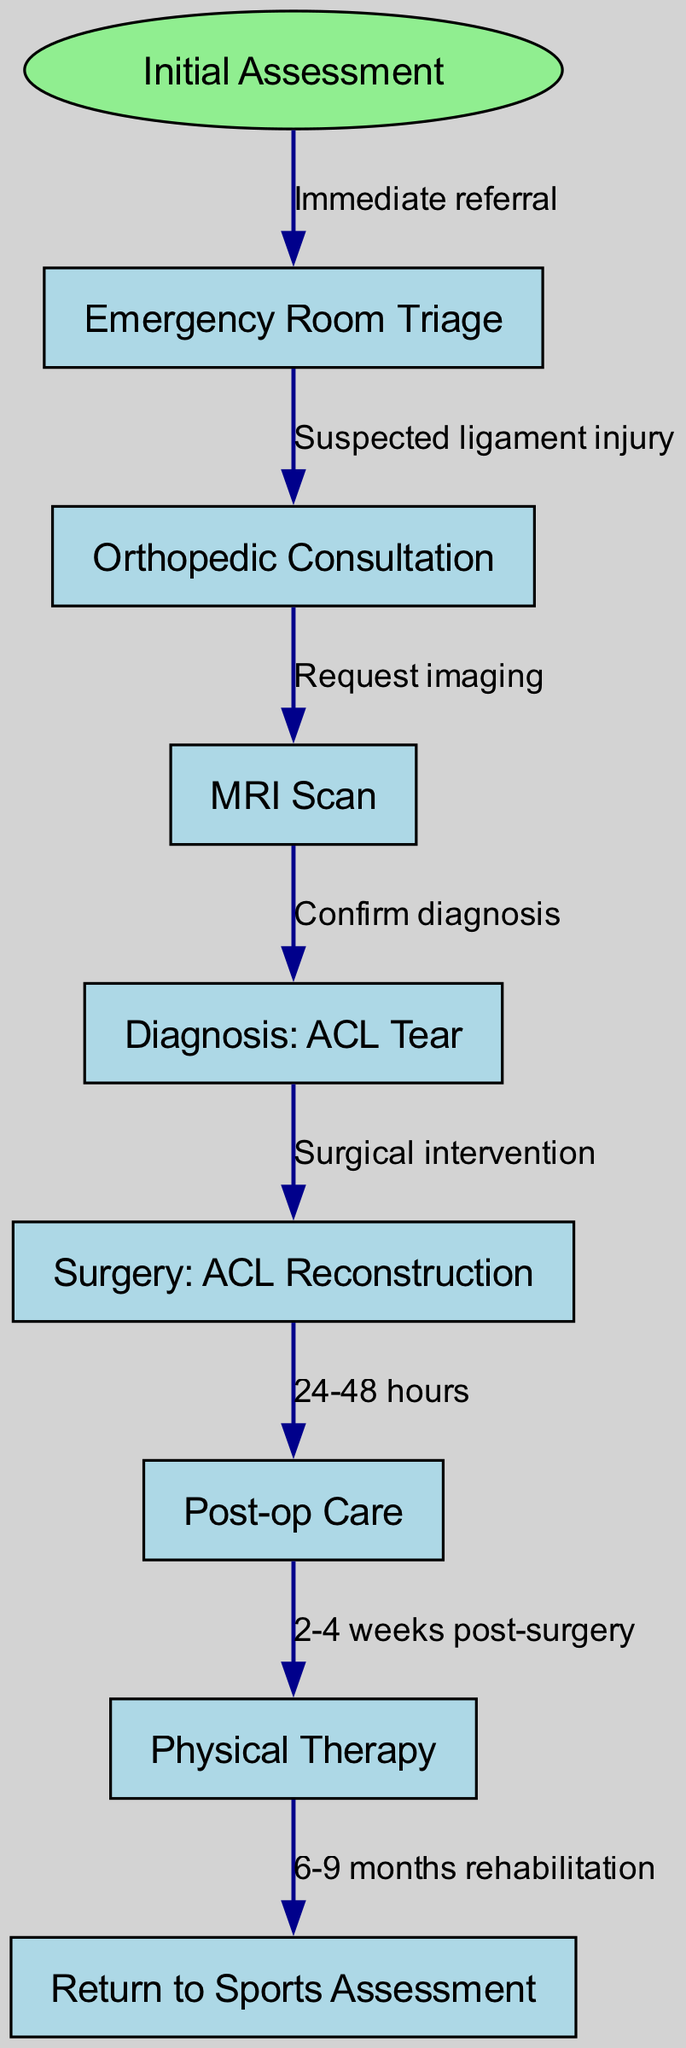What is the first step in the treatment pathway? The first step in the treatment pathway is "Emergency Room Triage," which is the initial assessment stage. This is identified as the starting point in the diagram.
Answer: Emergency Room Triage How many nodes are there in the diagram? The diagram contains a total of eight nodes, including the starting point. The nodes are listed under the "nodes" section in the provided data.
Answer: Eight What is the diagnosis after the MRI scan? After the MRI scan, the diagnosis confirmed is "ACL Tear," as indicated by the flow from the MRI scan to the diagnosis node in the diagram.
Answer: ACL Tear What happens after the diagnosis of ACL Tear? After the diagnosis of ACL Tear, the next step is "Surgery: ACL Reconstruction," representing the surgical intervention required to treat the injury, as outlined by the flow in the diagram.
Answer: Surgery: ACL Reconstruction How long after surgery does physical therapy begin? Physical therapy begins 2-4 weeks post-surgery, which is specified as the duration before starting rehabilitation in the pathway.
Answer: 2-4 weeks What is the total duration of rehabilitation before returning to sports? The total duration of rehabilitation before returning to sports is 6-9 months, as indicated in the final part of the pathway where physical therapy leads to return to sports assessment.
Answer: 6-9 months What is the immediate referral from the initial assessment? The immediate referral from the initial assessment is to "Emergency Room Triage," where the patient is directed due to potential injury, as shown in the directed edge from the start to this node.
Answer: Emergency Room Triage What imaging is requested after the orthopedic consultation? After the orthopedic consultation, an "MRI Scan" is requested as part of the diagnostic process, linking the consultation node to the imaging node in the diagram.
Answer: MRI Scan 